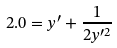Convert formula to latex. <formula><loc_0><loc_0><loc_500><loc_500>2 . 0 = y ^ { \prime } + \frac { 1 } { 2 y ^ { \prime 2 } }</formula> 